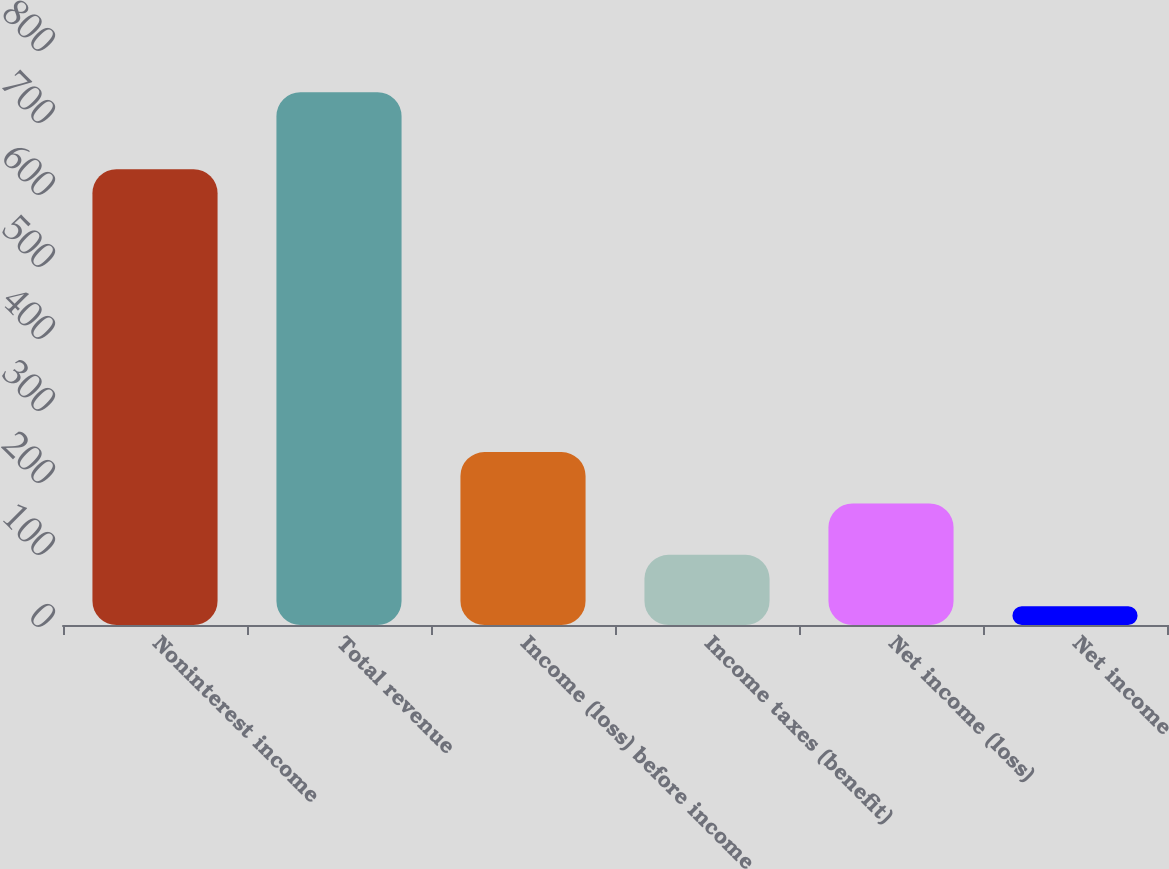Convert chart to OTSL. <chart><loc_0><loc_0><loc_500><loc_500><bar_chart><fcel>Noninterest income<fcel>Total revenue<fcel>Income (loss) before income<fcel>Income taxes (benefit)<fcel>Net income (loss)<fcel>Net income<nl><fcel>633<fcel>740<fcel>240.2<fcel>97.4<fcel>168.8<fcel>26<nl></chart> 